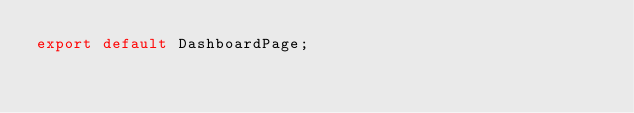Convert code to text. <code><loc_0><loc_0><loc_500><loc_500><_JavaScript_>export default DashboardPage;</code> 